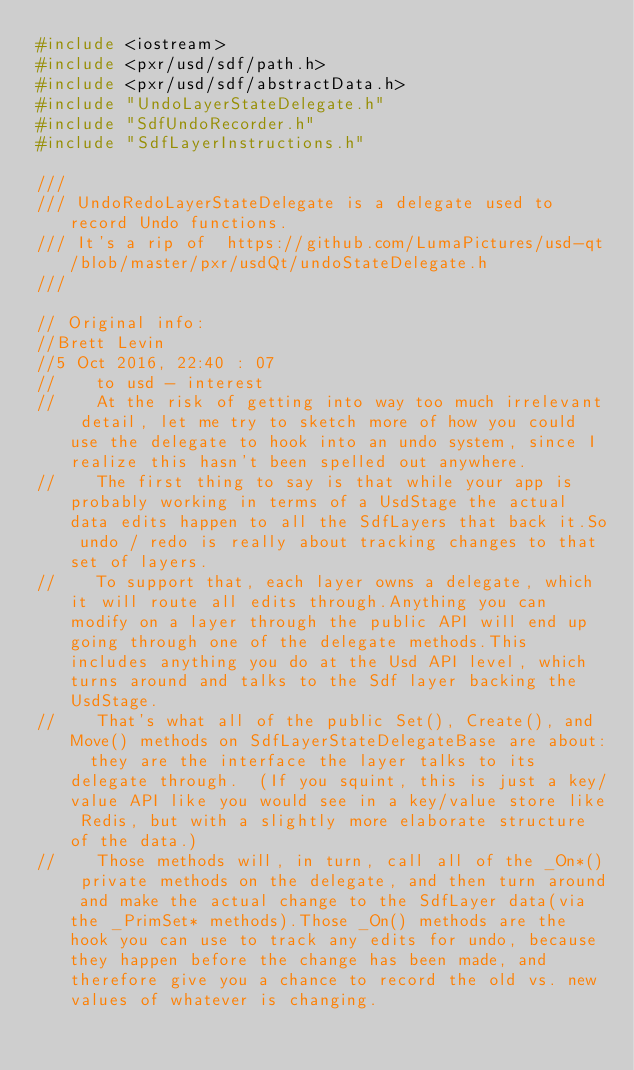<code> <loc_0><loc_0><loc_500><loc_500><_C++_>#include <iostream>
#include <pxr/usd/sdf/path.h>
#include <pxr/usd/sdf/abstractData.h>
#include "UndoLayerStateDelegate.h"
#include "SdfUndoRecorder.h"
#include "SdfLayerInstructions.h"

///
/// UndoRedoLayerStateDelegate is a delegate used to record Undo functions.
/// It's a rip of  https://github.com/LumaPictures/usd-qt/blob/master/pxr/usdQt/undoStateDelegate.h
///

// Original info:
//Brett Levin
//5 Oct 2016, 22:40 : 07
//    to usd - interest
//    At the risk of getting into way too much irrelevant detail, let me try to sketch more of how you could use the delegate to hook into an undo system, since I realize this hasn't been spelled out anywhere.
//    The first thing to say is that while your app is probably working in terms of a UsdStage the actual data edits happen to all the SdfLayers that back it.So undo / redo is really about tracking changes to that set of layers.
//    To support that, each layer owns a delegate, which it will route all edits through.Anything you can modify on a layer through the public API will end up going through one of the delegate methods.This includes anything you do at the Usd API level, which turns around and talks to the Sdf layer backing the UsdStage.
//    That's what all of the public Set(), Create(), and Move() methods on SdfLayerStateDelegateBase are about:  they are the interface the layer talks to its delegate through.  (If you squint, this is just a key/value API like you would see in a key/value store like Redis, but with a slightly more elaborate structure of the data.)
//    Those methods will, in turn, call all of the _On*() private methods on the delegate, and then turn around and make the actual change to the SdfLayer data(via the _PrimSet* methods).Those _On() methods are the hook you can use to track any edits for undo, because they happen before the change has been made, and therefore give you a chance to record the old vs. new values of whatever is changing.</code> 